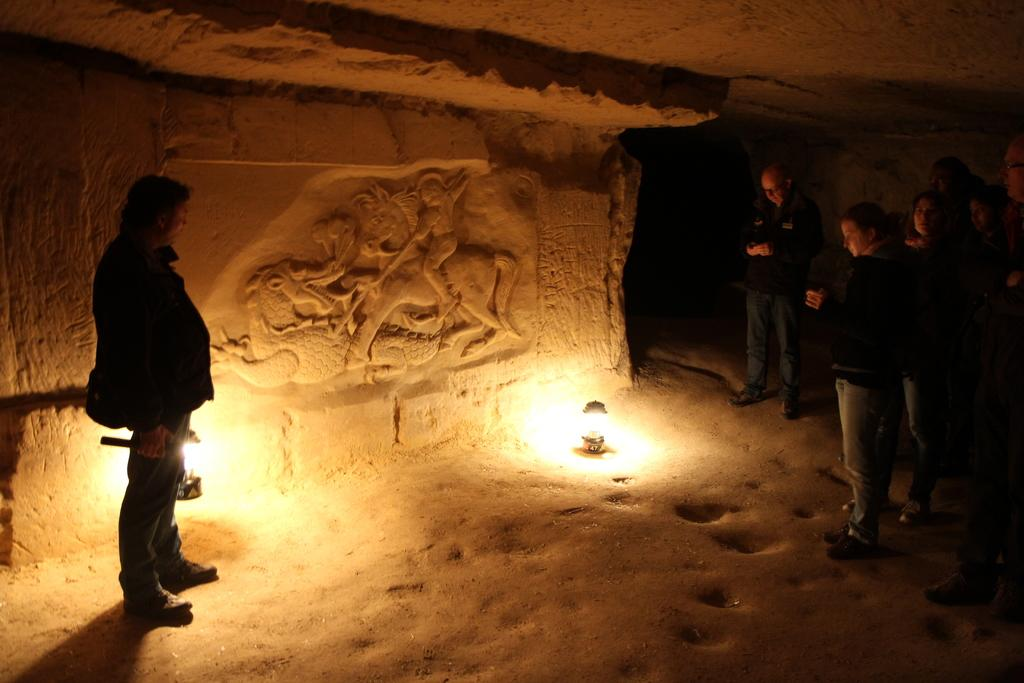What is the main object on the ground in the image? There is an object on the ground in the image, but the specific object is not mentioned in the facts. Can you describe the people in the image? There are people in the image, but their appearance or actions are not specified in the facts. What type of structure is visible in the image? There is a roof in the image, which suggests the presence of a building or shelter. What is the sculpture on the wall in the image? The facts mention a sculpture on a wall in the image, but the specific sculpture is not described. What other unspecified objects can be seen in the image? There are other unspecified objects in the image, but their nature or appearance is not mentioned in the facts. What type of elbow can be seen in the image? There is no mention of an elbow in the image, so it cannot be seen or described. 